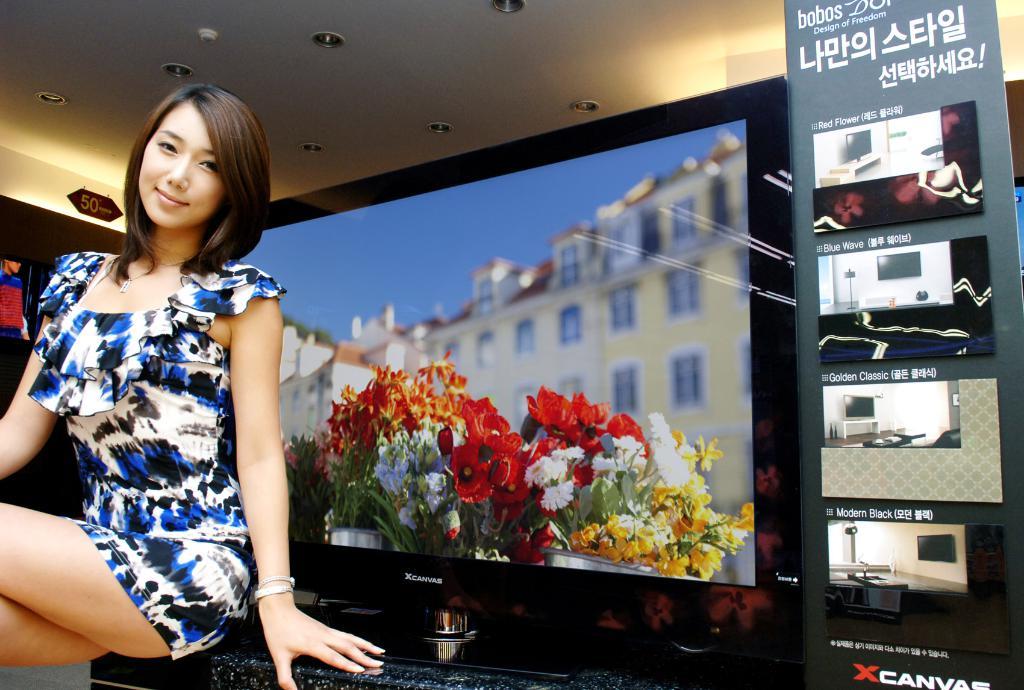What brand of tv is on display?
Your answer should be compact. Xcanvas. What's the name of the tv model on the bottom of the poster?
Your answer should be very brief. Xcanvas. 